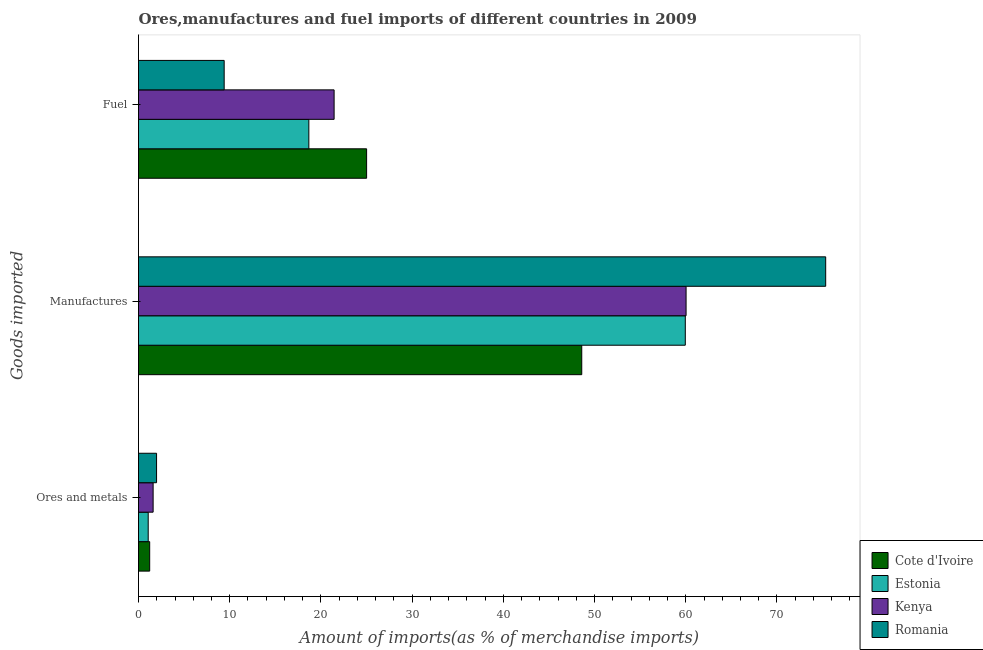How many different coloured bars are there?
Your answer should be very brief. 4. How many groups of bars are there?
Provide a succinct answer. 3. Are the number of bars on each tick of the Y-axis equal?
Your answer should be compact. Yes. What is the label of the 3rd group of bars from the top?
Give a very brief answer. Ores and metals. What is the percentage of ores and metals imports in Kenya?
Give a very brief answer. 1.6. Across all countries, what is the maximum percentage of manufactures imports?
Your answer should be very brief. 75.34. Across all countries, what is the minimum percentage of fuel imports?
Keep it short and to the point. 9.39. In which country was the percentage of ores and metals imports maximum?
Make the answer very short. Romania. In which country was the percentage of fuel imports minimum?
Your answer should be compact. Romania. What is the total percentage of manufactures imports in the graph?
Give a very brief answer. 243.92. What is the difference between the percentage of ores and metals imports in Estonia and that in Kenya?
Your response must be concise. -0.54. What is the difference between the percentage of fuel imports in Cote d'Ivoire and the percentage of manufactures imports in Kenya?
Provide a short and direct response. -35.03. What is the average percentage of manufactures imports per country?
Your answer should be compact. 60.98. What is the difference between the percentage of manufactures imports and percentage of ores and metals imports in Kenya?
Your answer should be very brief. 58.43. In how many countries, is the percentage of fuel imports greater than 54 %?
Your answer should be compact. 0. What is the ratio of the percentage of fuel imports in Cote d'Ivoire to that in Estonia?
Make the answer very short. 1.34. Is the percentage of manufactures imports in Kenya less than that in Romania?
Make the answer very short. Yes. What is the difference between the highest and the second highest percentage of manufactures imports?
Offer a very short reply. 15.31. What is the difference between the highest and the lowest percentage of ores and metals imports?
Provide a succinct answer. 0.92. What does the 4th bar from the top in Fuel represents?
Your response must be concise. Cote d'Ivoire. What does the 2nd bar from the bottom in Fuel represents?
Keep it short and to the point. Estonia. How many countries are there in the graph?
Your response must be concise. 4. What is the difference between two consecutive major ticks on the X-axis?
Your answer should be compact. 10. Does the graph contain grids?
Offer a terse response. No. Where does the legend appear in the graph?
Give a very brief answer. Bottom right. How are the legend labels stacked?
Your answer should be very brief. Vertical. What is the title of the graph?
Ensure brevity in your answer.  Ores,manufactures and fuel imports of different countries in 2009. Does "Finland" appear as one of the legend labels in the graph?
Offer a terse response. No. What is the label or title of the X-axis?
Your response must be concise. Amount of imports(as % of merchandise imports). What is the label or title of the Y-axis?
Make the answer very short. Goods imported. What is the Amount of imports(as % of merchandise imports) of Cote d'Ivoire in Ores and metals?
Make the answer very short. 1.23. What is the Amount of imports(as % of merchandise imports) of Estonia in Ores and metals?
Ensure brevity in your answer.  1.06. What is the Amount of imports(as % of merchandise imports) of Kenya in Ores and metals?
Your answer should be very brief. 1.6. What is the Amount of imports(as % of merchandise imports) in Romania in Ores and metals?
Give a very brief answer. 1.98. What is the Amount of imports(as % of merchandise imports) of Cote d'Ivoire in Manufactures?
Your response must be concise. 48.6. What is the Amount of imports(as % of merchandise imports) in Estonia in Manufactures?
Your answer should be very brief. 59.95. What is the Amount of imports(as % of merchandise imports) of Kenya in Manufactures?
Keep it short and to the point. 60.03. What is the Amount of imports(as % of merchandise imports) of Romania in Manufactures?
Your answer should be compact. 75.34. What is the Amount of imports(as % of merchandise imports) of Cote d'Ivoire in Fuel?
Offer a terse response. 25.01. What is the Amount of imports(as % of merchandise imports) in Estonia in Fuel?
Offer a terse response. 18.67. What is the Amount of imports(as % of merchandise imports) in Kenya in Fuel?
Your answer should be compact. 21.45. What is the Amount of imports(as % of merchandise imports) in Romania in Fuel?
Make the answer very short. 9.39. Across all Goods imported, what is the maximum Amount of imports(as % of merchandise imports) in Cote d'Ivoire?
Ensure brevity in your answer.  48.6. Across all Goods imported, what is the maximum Amount of imports(as % of merchandise imports) of Estonia?
Keep it short and to the point. 59.95. Across all Goods imported, what is the maximum Amount of imports(as % of merchandise imports) in Kenya?
Keep it short and to the point. 60.03. Across all Goods imported, what is the maximum Amount of imports(as % of merchandise imports) of Romania?
Make the answer very short. 75.34. Across all Goods imported, what is the minimum Amount of imports(as % of merchandise imports) in Cote d'Ivoire?
Make the answer very short. 1.23. Across all Goods imported, what is the minimum Amount of imports(as % of merchandise imports) of Estonia?
Offer a terse response. 1.06. Across all Goods imported, what is the minimum Amount of imports(as % of merchandise imports) of Kenya?
Provide a succinct answer. 1.6. Across all Goods imported, what is the minimum Amount of imports(as % of merchandise imports) in Romania?
Your answer should be very brief. 1.98. What is the total Amount of imports(as % of merchandise imports) in Cote d'Ivoire in the graph?
Your response must be concise. 74.83. What is the total Amount of imports(as % of merchandise imports) in Estonia in the graph?
Keep it short and to the point. 79.69. What is the total Amount of imports(as % of merchandise imports) in Kenya in the graph?
Provide a short and direct response. 83.08. What is the total Amount of imports(as % of merchandise imports) in Romania in the graph?
Offer a terse response. 86.71. What is the difference between the Amount of imports(as % of merchandise imports) in Cote d'Ivoire in Ores and metals and that in Manufactures?
Ensure brevity in your answer.  -47.37. What is the difference between the Amount of imports(as % of merchandise imports) in Estonia in Ores and metals and that in Manufactures?
Provide a short and direct response. -58.88. What is the difference between the Amount of imports(as % of merchandise imports) in Kenya in Ores and metals and that in Manufactures?
Ensure brevity in your answer.  -58.43. What is the difference between the Amount of imports(as % of merchandise imports) of Romania in Ores and metals and that in Manufactures?
Provide a short and direct response. -73.36. What is the difference between the Amount of imports(as % of merchandise imports) in Cote d'Ivoire in Ores and metals and that in Fuel?
Your response must be concise. -23.78. What is the difference between the Amount of imports(as % of merchandise imports) of Estonia in Ores and metals and that in Fuel?
Keep it short and to the point. -17.61. What is the difference between the Amount of imports(as % of merchandise imports) of Kenya in Ores and metals and that in Fuel?
Provide a short and direct response. -19.84. What is the difference between the Amount of imports(as % of merchandise imports) of Romania in Ores and metals and that in Fuel?
Keep it short and to the point. -7.41. What is the difference between the Amount of imports(as % of merchandise imports) of Cote d'Ivoire in Manufactures and that in Fuel?
Offer a terse response. 23.59. What is the difference between the Amount of imports(as % of merchandise imports) of Estonia in Manufactures and that in Fuel?
Provide a short and direct response. 41.27. What is the difference between the Amount of imports(as % of merchandise imports) of Kenya in Manufactures and that in Fuel?
Offer a terse response. 38.59. What is the difference between the Amount of imports(as % of merchandise imports) of Romania in Manufactures and that in Fuel?
Offer a very short reply. 65.95. What is the difference between the Amount of imports(as % of merchandise imports) in Cote d'Ivoire in Ores and metals and the Amount of imports(as % of merchandise imports) in Estonia in Manufactures?
Provide a short and direct response. -58.72. What is the difference between the Amount of imports(as % of merchandise imports) in Cote d'Ivoire in Ores and metals and the Amount of imports(as % of merchandise imports) in Kenya in Manufactures?
Keep it short and to the point. -58.81. What is the difference between the Amount of imports(as % of merchandise imports) of Cote d'Ivoire in Ores and metals and the Amount of imports(as % of merchandise imports) of Romania in Manufactures?
Provide a short and direct response. -74.11. What is the difference between the Amount of imports(as % of merchandise imports) in Estonia in Ores and metals and the Amount of imports(as % of merchandise imports) in Kenya in Manufactures?
Ensure brevity in your answer.  -58.97. What is the difference between the Amount of imports(as % of merchandise imports) in Estonia in Ores and metals and the Amount of imports(as % of merchandise imports) in Romania in Manufactures?
Your response must be concise. -74.28. What is the difference between the Amount of imports(as % of merchandise imports) of Kenya in Ores and metals and the Amount of imports(as % of merchandise imports) of Romania in Manufactures?
Offer a terse response. -73.74. What is the difference between the Amount of imports(as % of merchandise imports) of Cote d'Ivoire in Ores and metals and the Amount of imports(as % of merchandise imports) of Estonia in Fuel?
Ensure brevity in your answer.  -17.45. What is the difference between the Amount of imports(as % of merchandise imports) in Cote d'Ivoire in Ores and metals and the Amount of imports(as % of merchandise imports) in Kenya in Fuel?
Give a very brief answer. -20.22. What is the difference between the Amount of imports(as % of merchandise imports) in Cote d'Ivoire in Ores and metals and the Amount of imports(as % of merchandise imports) in Romania in Fuel?
Offer a terse response. -8.17. What is the difference between the Amount of imports(as % of merchandise imports) of Estonia in Ores and metals and the Amount of imports(as % of merchandise imports) of Kenya in Fuel?
Keep it short and to the point. -20.38. What is the difference between the Amount of imports(as % of merchandise imports) in Estonia in Ores and metals and the Amount of imports(as % of merchandise imports) in Romania in Fuel?
Offer a terse response. -8.33. What is the difference between the Amount of imports(as % of merchandise imports) of Kenya in Ores and metals and the Amount of imports(as % of merchandise imports) of Romania in Fuel?
Your answer should be very brief. -7.79. What is the difference between the Amount of imports(as % of merchandise imports) in Cote d'Ivoire in Manufactures and the Amount of imports(as % of merchandise imports) in Estonia in Fuel?
Offer a very short reply. 29.92. What is the difference between the Amount of imports(as % of merchandise imports) of Cote d'Ivoire in Manufactures and the Amount of imports(as % of merchandise imports) of Kenya in Fuel?
Offer a terse response. 27.15. What is the difference between the Amount of imports(as % of merchandise imports) in Cote d'Ivoire in Manufactures and the Amount of imports(as % of merchandise imports) in Romania in Fuel?
Your answer should be compact. 39.2. What is the difference between the Amount of imports(as % of merchandise imports) of Estonia in Manufactures and the Amount of imports(as % of merchandise imports) of Kenya in Fuel?
Ensure brevity in your answer.  38.5. What is the difference between the Amount of imports(as % of merchandise imports) in Estonia in Manufactures and the Amount of imports(as % of merchandise imports) in Romania in Fuel?
Ensure brevity in your answer.  50.56. What is the difference between the Amount of imports(as % of merchandise imports) in Kenya in Manufactures and the Amount of imports(as % of merchandise imports) in Romania in Fuel?
Provide a short and direct response. 50.64. What is the average Amount of imports(as % of merchandise imports) of Cote d'Ivoire per Goods imported?
Provide a short and direct response. 24.94. What is the average Amount of imports(as % of merchandise imports) in Estonia per Goods imported?
Your response must be concise. 26.56. What is the average Amount of imports(as % of merchandise imports) of Kenya per Goods imported?
Keep it short and to the point. 27.69. What is the average Amount of imports(as % of merchandise imports) in Romania per Goods imported?
Offer a very short reply. 28.9. What is the difference between the Amount of imports(as % of merchandise imports) of Cote d'Ivoire and Amount of imports(as % of merchandise imports) of Estonia in Ores and metals?
Ensure brevity in your answer.  0.16. What is the difference between the Amount of imports(as % of merchandise imports) in Cote d'Ivoire and Amount of imports(as % of merchandise imports) in Kenya in Ores and metals?
Make the answer very short. -0.38. What is the difference between the Amount of imports(as % of merchandise imports) in Cote d'Ivoire and Amount of imports(as % of merchandise imports) in Romania in Ores and metals?
Give a very brief answer. -0.75. What is the difference between the Amount of imports(as % of merchandise imports) of Estonia and Amount of imports(as % of merchandise imports) of Kenya in Ores and metals?
Offer a very short reply. -0.54. What is the difference between the Amount of imports(as % of merchandise imports) of Estonia and Amount of imports(as % of merchandise imports) of Romania in Ores and metals?
Your response must be concise. -0.92. What is the difference between the Amount of imports(as % of merchandise imports) in Kenya and Amount of imports(as % of merchandise imports) in Romania in Ores and metals?
Your response must be concise. -0.38. What is the difference between the Amount of imports(as % of merchandise imports) in Cote d'Ivoire and Amount of imports(as % of merchandise imports) in Estonia in Manufactures?
Provide a short and direct response. -11.35. What is the difference between the Amount of imports(as % of merchandise imports) of Cote d'Ivoire and Amount of imports(as % of merchandise imports) of Kenya in Manufactures?
Your answer should be very brief. -11.44. What is the difference between the Amount of imports(as % of merchandise imports) of Cote d'Ivoire and Amount of imports(as % of merchandise imports) of Romania in Manufactures?
Give a very brief answer. -26.74. What is the difference between the Amount of imports(as % of merchandise imports) in Estonia and Amount of imports(as % of merchandise imports) in Kenya in Manufactures?
Offer a terse response. -0.09. What is the difference between the Amount of imports(as % of merchandise imports) in Estonia and Amount of imports(as % of merchandise imports) in Romania in Manufactures?
Your response must be concise. -15.39. What is the difference between the Amount of imports(as % of merchandise imports) in Kenya and Amount of imports(as % of merchandise imports) in Romania in Manufactures?
Make the answer very short. -15.31. What is the difference between the Amount of imports(as % of merchandise imports) of Cote d'Ivoire and Amount of imports(as % of merchandise imports) of Estonia in Fuel?
Your answer should be very brief. 6.33. What is the difference between the Amount of imports(as % of merchandise imports) in Cote d'Ivoire and Amount of imports(as % of merchandise imports) in Kenya in Fuel?
Provide a succinct answer. 3.56. What is the difference between the Amount of imports(as % of merchandise imports) of Cote d'Ivoire and Amount of imports(as % of merchandise imports) of Romania in Fuel?
Make the answer very short. 15.62. What is the difference between the Amount of imports(as % of merchandise imports) in Estonia and Amount of imports(as % of merchandise imports) in Kenya in Fuel?
Make the answer very short. -2.77. What is the difference between the Amount of imports(as % of merchandise imports) in Estonia and Amount of imports(as % of merchandise imports) in Romania in Fuel?
Keep it short and to the point. 9.28. What is the difference between the Amount of imports(as % of merchandise imports) in Kenya and Amount of imports(as % of merchandise imports) in Romania in Fuel?
Offer a very short reply. 12.05. What is the ratio of the Amount of imports(as % of merchandise imports) in Cote d'Ivoire in Ores and metals to that in Manufactures?
Give a very brief answer. 0.03. What is the ratio of the Amount of imports(as % of merchandise imports) in Estonia in Ores and metals to that in Manufactures?
Give a very brief answer. 0.02. What is the ratio of the Amount of imports(as % of merchandise imports) in Kenya in Ores and metals to that in Manufactures?
Provide a short and direct response. 0.03. What is the ratio of the Amount of imports(as % of merchandise imports) in Romania in Ores and metals to that in Manufactures?
Offer a very short reply. 0.03. What is the ratio of the Amount of imports(as % of merchandise imports) in Cote d'Ivoire in Ores and metals to that in Fuel?
Make the answer very short. 0.05. What is the ratio of the Amount of imports(as % of merchandise imports) of Estonia in Ores and metals to that in Fuel?
Keep it short and to the point. 0.06. What is the ratio of the Amount of imports(as % of merchandise imports) of Kenya in Ores and metals to that in Fuel?
Offer a terse response. 0.07. What is the ratio of the Amount of imports(as % of merchandise imports) of Romania in Ores and metals to that in Fuel?
Provide a short and direct response. 0.21. What is the ratio of the Amount of imports(as % of merchandise imports) of Cote d'Ivoire in Manufactures to that in Fuel?
Offer a very short reply. 1.94. What is the ratio of the Amount of imports(as % of merchandise imports) in Estonia in Manufactures to that in Fuel?
Ensure brevity in your answer.  3.21. What is the ratio of the Amount of imports(as % of merchandise imports) in Kenya in Manufactures to that in Fuel?
Make the answer very short. 2.8. What is the ratio of the Amount of imports(as % of merchandise imports) in Romania in Manufactures to that in Fuel?
Ensure brevity in your answer.  8.02. What is the difference between the highest and the second highest Amount of imports(as % of merchandise imports) in Cote d'Ivoire?
Your response must be concise. 23.59. What is the difference between the highest and the second highest Amount of imports(as % of merchandise imports) in Estonia?
Offer a very short reply. 41.27. What is the difference between the highest and the second highest Amount of imports(as % of merchandise imports) of Kenya?
Ensure brevity in your answer.  38.59. What is the difference between the highest and the second highest Amount of imports(as % of merchandise imports) of Romania?
Your response must be concise. 65.95. What is the difference between the highest and the lowest Amount of imports(as % of merchandise imports) in Cote d'Ivoire?
Your answer should be compact. 47.37. What is the difference between the highest and the lowest Amount of imports(as % of merchandise imports) of Estonia?
Make the answer very short. 58.88. What is the difference between the highest and the lowest Amount of imports(as % of merchandise imports) in Kenya?
Keep it short and to the point. 58.43. What is the difference between the highest and the lowest Amount of imports(as % of merchandise imports) in Romania?
Your response must be concise. 73.36. 